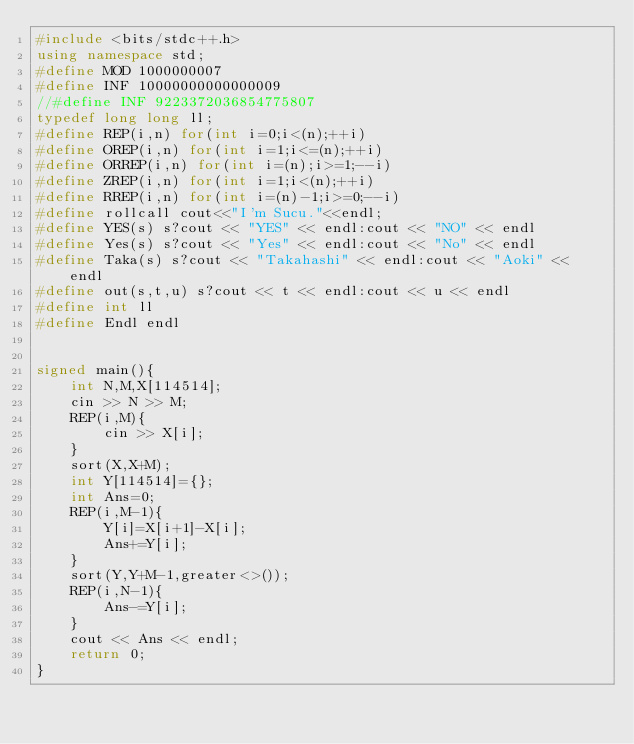Convert code to text. <code><loc_0><loc_0><loc_500><loc_500><_C++_>#include <bits/stdc++.h>
using namespace std;
#define MOD 1000000007
#define INF 10000000000000009
//#define INF 9223372036854775807
typedef long long ll;
#define REP(i,n) for(int i=0;i<(n);++i)
#define OREP(i,n) for(int i=1;i<=(n);++i)
#define ORREP(i,n) for(int i=(n);i>=1;--i)
#define ZREP(i,n) for(int i=1;i<(n);++i)
#define RREP(i,n) for(int i=(n)-1;i>=0;--i)
#define rollcall cout<<"I'm Sucu."<<endl;
#define YES(s) s?cout << "YES" << endl:cout << "NO" << endl
#define Yes(s) s?cout << "Yes" << endl:cout << "No" << endl
#define Taka(s) s?cout << "Takahashi" << endl:cout << "Aoki" << endl
#define out(s,t,u) s?cout << t << endl:cout << u << endl
#define int ll
#define Endl endl


signed main(){
    int N,M,X[114514];
    cin >> N >> M;
    REP(i,M){
        cin >> X[i];
    }
    sort(X,X+M);
    int Y[114514]={};
    int Ans=0;
    REP(i,M-1){
        Y[i]=X[i+1]-X[i];
        Ans+=Y[i];
    }
    sort(Y,Y+M-1,greater<>());
    REP(i,N-1){
        Ans-=Y[i];
    }
    cout << Ans << endl;
    return 0;
}</code> 